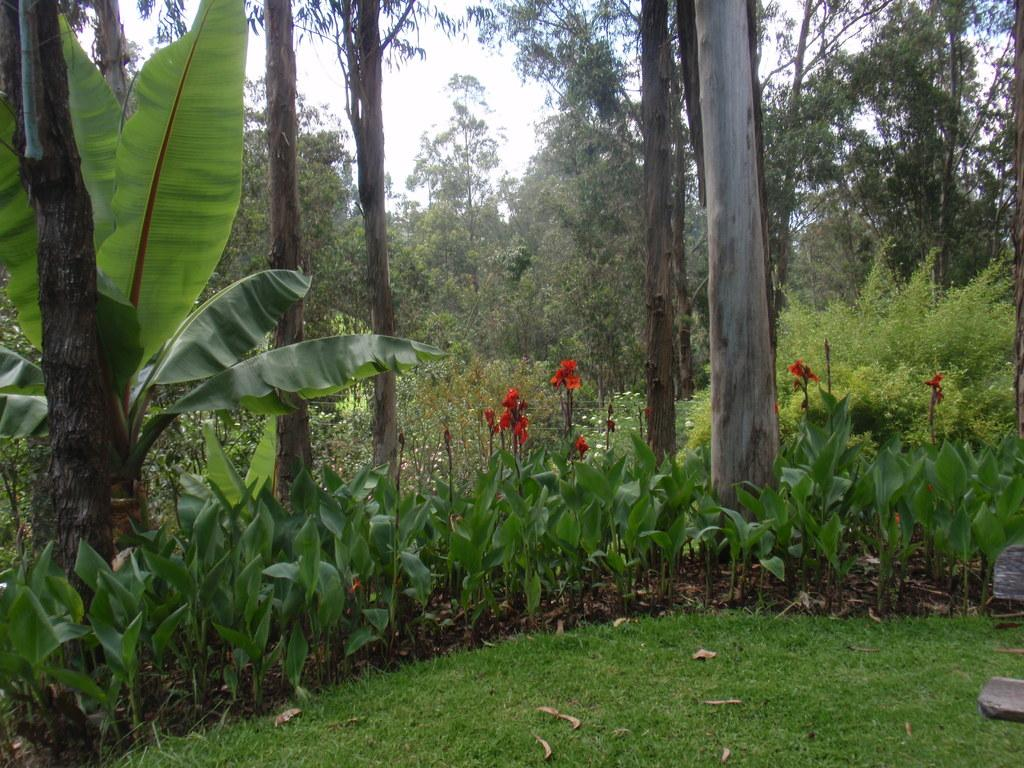What type of surface is visible at the bottom of the image? There is grass on the surface at the bottom of the image. What types of vegetation can be seen in the image? There are plants and flowers in the image. What can be seen in the background of the image? There are trees and the sky visible in the background of the image. What statement can be made about the salt content in the image? There is no mention of salt in the image, so it cannot be determined if there is any salt present. 